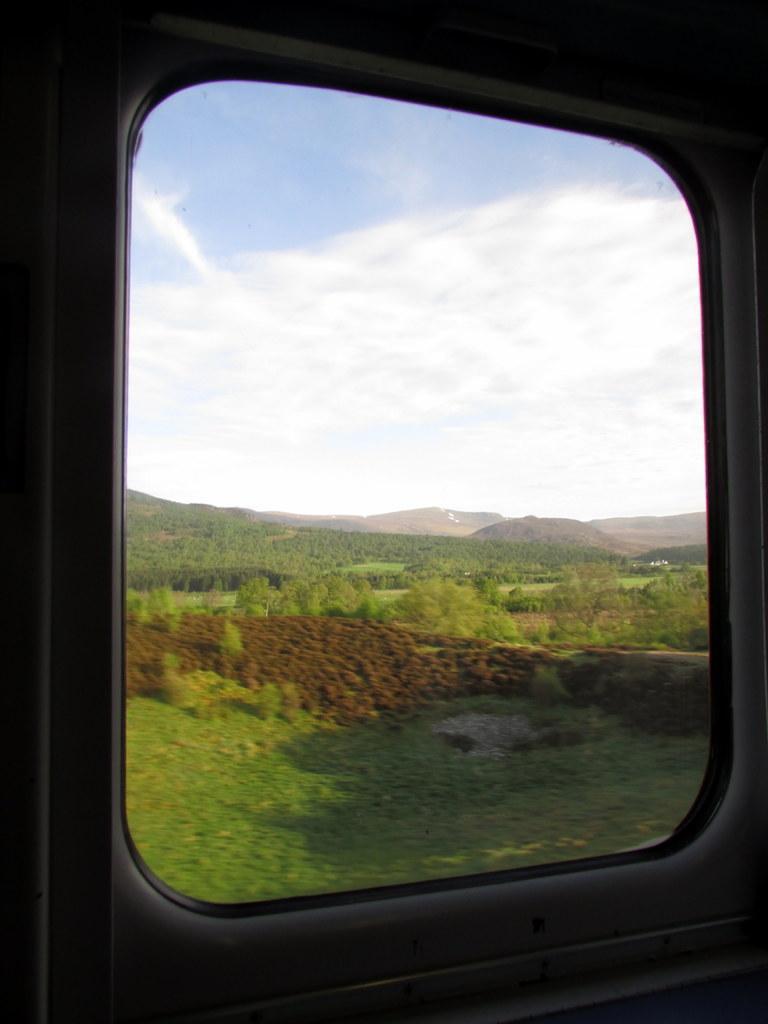Could you give a brief overview of what you see in this image? In this image we can see trees and a sky through this glass window. 